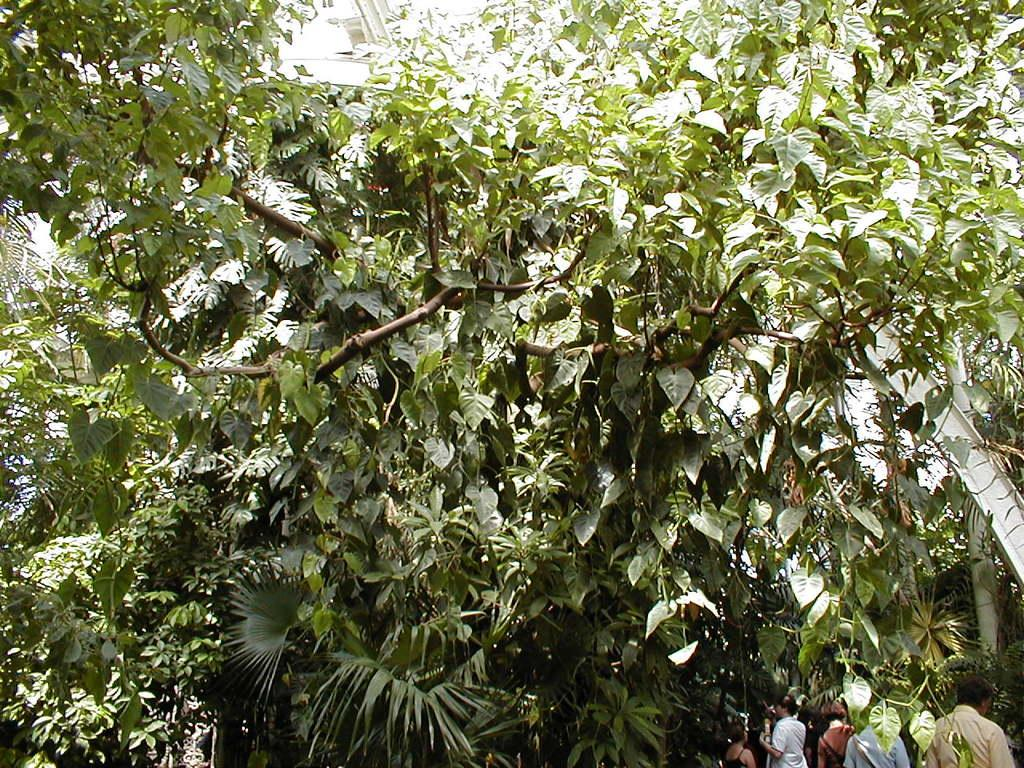What type of natural elements can be seen in the image? There are trees in the image. Are there any human subjects in the image? Yes, there are people in the image. Can you describe the object on the right side of the image? Unfortunately, the facts provided do not give enough information to describe the object on the right side of the image. What type of toys are the children playing with in the image? There is no information about children or toys in the image, so we cannot answer this question. 